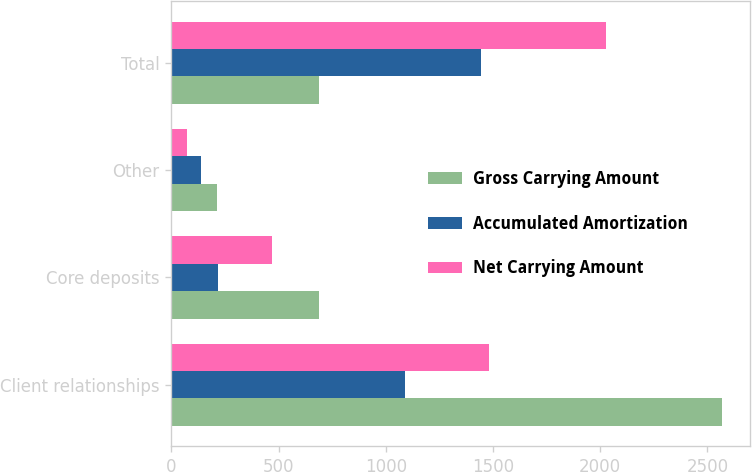<chart> <loc_0><loc_0><loc_500><loc_500><stacked_bar_chart><ecel><fcel>Client relationships<fcel>Core deposits<fcel>Other<fcel>Total<nl><fcel>Gross Carrying Amount<fcel>2569<fcel>688<fcel>214<fcel>688<nl><fcel>Accumulated Amortization<fcel>1088<fcel>219<fcel>139<fcel>1446<nl><fcel>Net Carrying Amount<fcel>1481<fcel>469<fcel>75<fcel>2025<nl></chart> 